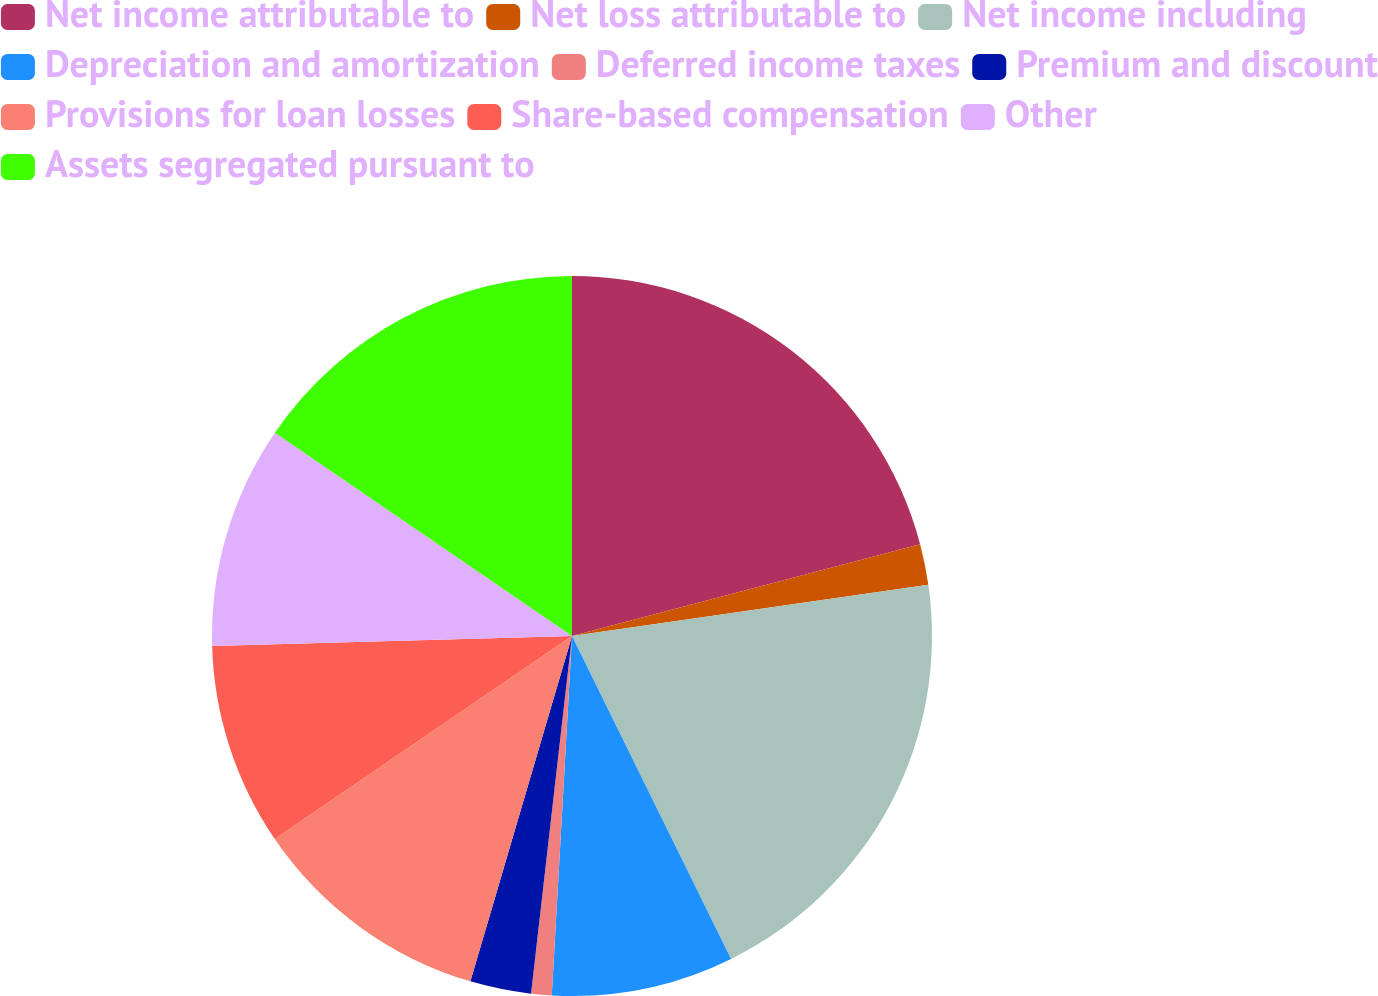<chart> <loc_0><loc_0><loc_500><loc_500><pie_chart><fcel>Net income attributable to<fcel>Net loss attributable to<fcel>Net income including<fcel>Depreciation and amortization<fcel>Deferred income taxes<fcel>Premium and discount<fcel>Provisions for loan losses<fcel>Share-based compensation<fcel>Other<fcel>Assets segregated pursuant to<nl><fcel>20.9%<fcel>1.83%<fcel>19.99%<fcel>8.18%<fcel>0.92%<fcel>2.74%<fcel>10.91%<fcel>9.09%<fcel>10.0%<fcel>15.45%<nl></chart> 